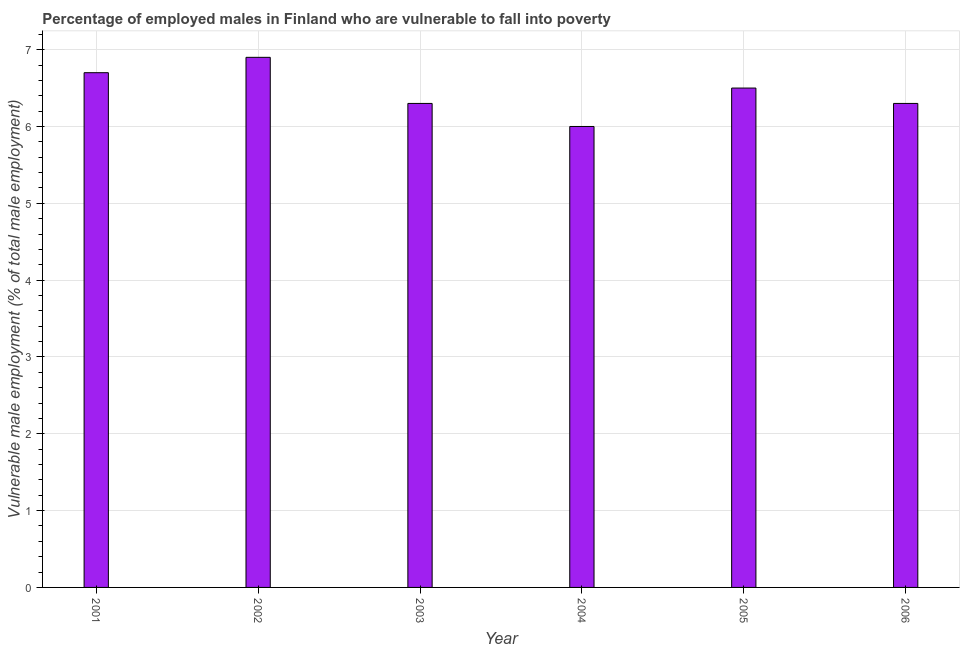Does the graph contain any zero values?
Offer a terse response. No. Does the graph contain grids?
Your answer should be very brief. Yes. What is the title of the graph?
Provide a succinct answer. Percentage of employed males in Finland who are vulnerable to fall into poverty. What is the label or title of the Y-axis?
Your answer should be compact. Vulnerable male employment (% of total male employment). Across all years, what is the maximum percentage of employed males who are vulnerable to fall into poverty?
Offer a very short reply. 6.9. Across all years, what is the minimum percentage of employed males who are vulnerable to fall into poverty?
Your answer should be very brief. 6. In which year was the percentage of employed males who are vulnerable to fall into poverty minimum?
Your answer should be compact. 2004. What is the sum of the percentage of employed males who are vulnerable to fall into poverty?
Give a very brief answer. 38.7. What is the difference between the percentage of employed males who are vulnerable to fall into poverty in 2003 and 2005?
Keep it short and to the point. -0.2. What is the average percentage of employed males who are vulnerable to fall into poverty per year?
Give a very brief answer. 6.45. What is the median percentage of employed males who are vulnerable to fall into poverty?
Ensure brevity in your answer.  6.4. In how many years, is the percentage of employed males who are vulnerable to fall into poverty greater than 2.8 %?
Your answer should be compact. 6. What is the ratio of the percentage of employed males who are vulnerable to fall into poverty in 2001 to that in 2003?
Keep it short and to the point. 1.06. Is the percentage of employed males who are vulnerable to fall into poverty in 2002 less than that in 2006?
Make the answer very short. No. Is the difference between the percentage of employed males who are vulnerable to fall into poverty in 2005 and 2006 greater than the difference between any two years?
Provide a short and direct response. No. What is the difference between the highest and the second highest percentage of employed males who are vulnerable to fall into poverty?
Give a very brief answer. 0.2. What is the difference between the highest and the lowest percentage of employed males who are vulnerable to fall into poverty?
Make the answer very short. 0.9. In how many years, is the percentage of employed males who are vulnerable to fall into poverty greater than the average percentage of employed males who are vulnerable to fall into poverty taken over all years?
Provide a succinct answer. 3. Are all the bars in the graph horizontal?
Keep it short and to the point. No. What is the Vulnerable male employment (% of total male employment) of 2001?
Make the answer very short. 6.7. What is the Vulnerable male employment (% of total male employment) in 2002?
Provide a short and direct response. 6.9. What is the Vulnerable male employment (% of total male employment) in 2003?
Provide a succinct answer. 6.3. What is the Vulnerable male employment (% of total male employment) in 2005?
Your answer should be compact. 6.5. What is the Vulnerable male employment (% of total male employment) in 2006?
Offer a terse response. 6.3. What is the difference between the Vulnerable male employment (% of total male employment) in 2001 and 2002?
Provide a short and direct response. -0.2. What is the difference between the Vulnerable male employment (% of total male employment) in 2002 and 2003?
Your answer should be very brief. 0.6. What is the difference between the Vulnerable male employment (% of total male employment) in 2003 and 2006?
Offer a terse response. 0. What is the difference between the Vulnerable male employment (% of total male employment) in 2004 and 2006?
Make the answer very short. -0.3. What is the difference between the Vulnerable male employment (% of total male employment) in 2005 and 2006?
Your response must be concise. 0.2. What is the ratio of the Vulnerable male employment (% of total male employment) in 2001 to that in 2003?
Your answer should be very brief. 1.06. What is the ratio of the Vulnerable male employment (% of total male employment) in 2001 to that in 2004?
Your response must be concise. 1.12. What is the ratio of the Vulnerable male employment (% of total male employment) in 2001 to that in 2005?
Keep it short and to the point. 1.03. What is the ratio of the Vulnerable male employment (% of total male employment) in 2001 to that in 2006?
Your response must be concise. 1.06. What is the ratio of the Vulnerable male employment (% of total male employment) in 2002 to that in 2003?
Offer a very short reply. 1.09. What is the ratio of the Vulnerable male employment (% of total male employment) in 2002 to that in 2004?
Offer a terse response. 1.15. What is the ratio of the Vulnerable male employment (% of total male employment) in 2002 to that in 2005?
Offer a terse response. 1.06. What is the ratio of the Vulnerable male employment (% of total male employment) in 2002 to that in 2006?
Offer a very short reply. 1.09. What is the ratio of the Vulnerable male employment (% of total male employment) in 2003 to that in 2005?
Your answer should be very brief. 0.97. What is the ratio of the Vulnerable male employment (% of total male employment) in 2003 to that in 2006?
Your answer should be compact. 1. What is the ratio of the Vulnerable male employment (% of total male employment) in 2004 to that in 2005?
Ensure brevity in your answer.  0.92. What is the ratio of the Vulnerable male employment (% of total male employment) in 2004 to that in 2006?
Your answer should be compact. 0.95. What is the ratio of the Vulnerable male employment (% of total male employment) in 2005 to that in 2006?
Offer a very short reply. 1.03. 